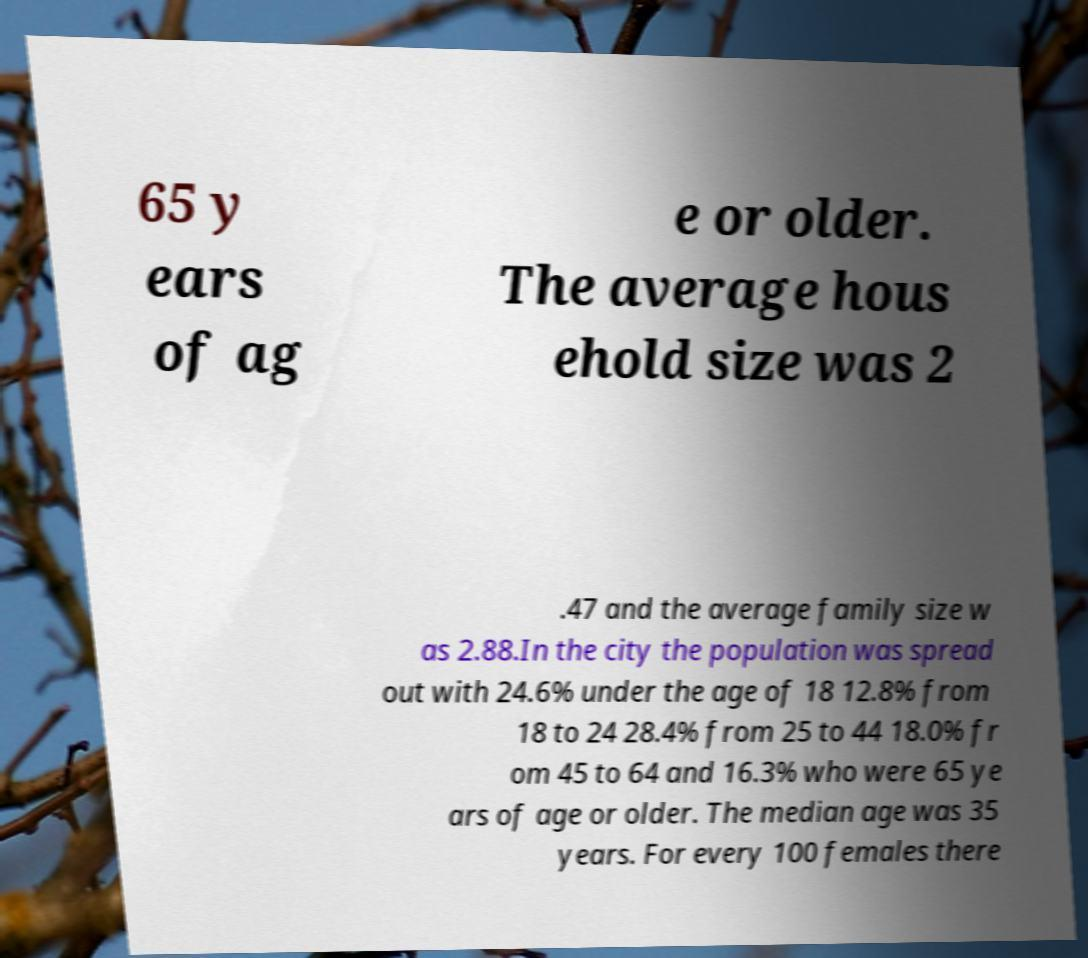What messages or text are displayed in this image? I need them in a readable, typed format. 65 y ears of ag e or older. The average hous ehold size was 2 .47 and the average family size w as 2.88.In the city the population was spread out with 24.6% under the age of 18 12.8% from 18 to 24 28.4% from 25 to 44 18.0% fr om 45 to 64 and 16.3% who were 65 ye ars of age or older. The median age was 35 years. For every 100 females there 